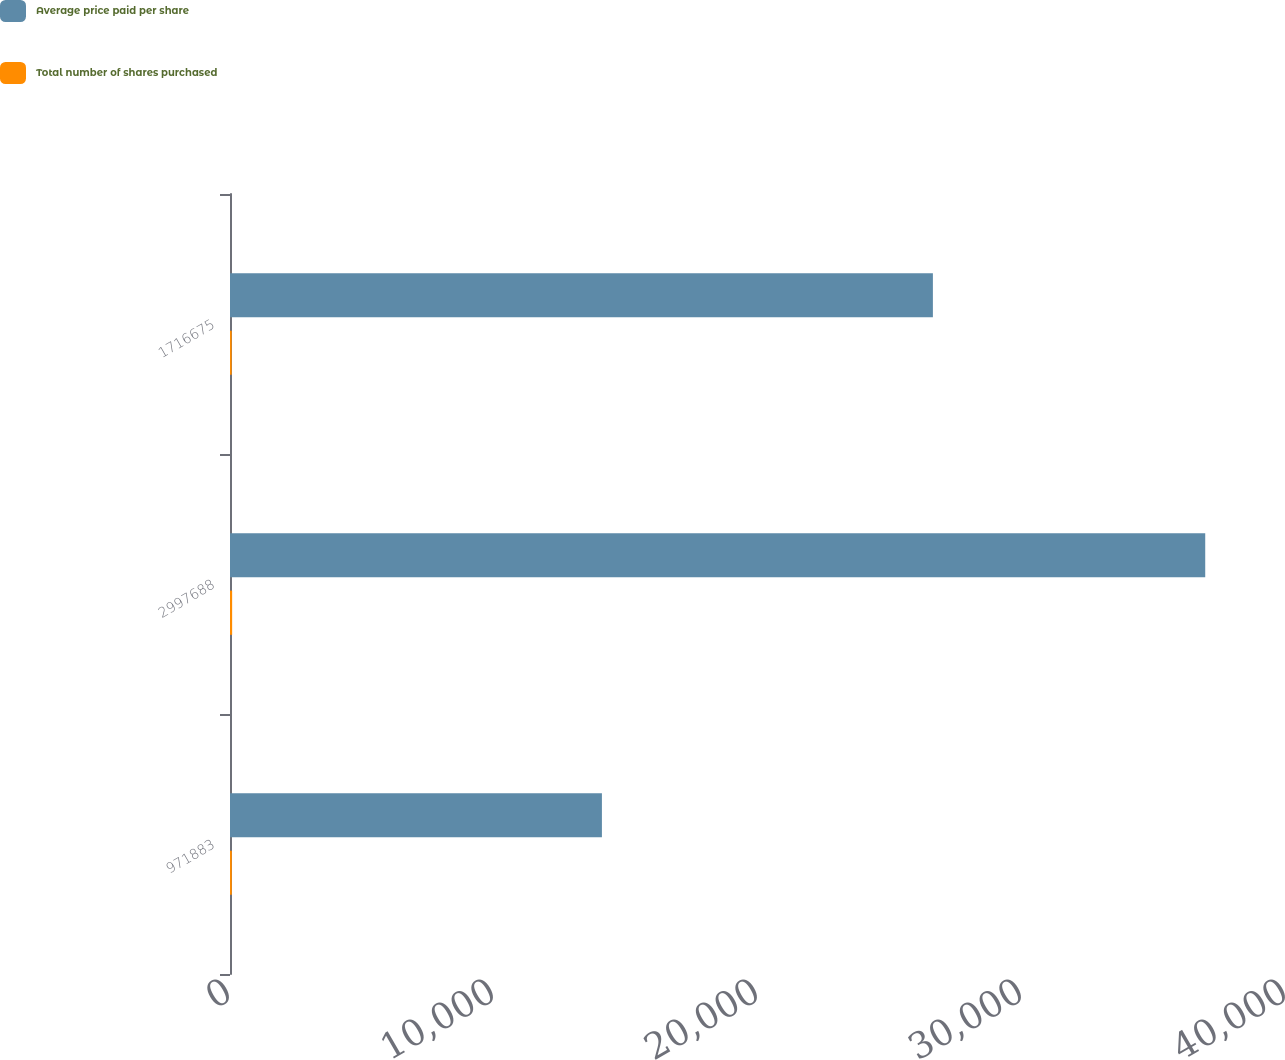<chart> <loc_0><loc_0><loc_500><loc_500><stacked_bar_chart><ecel><fcel>971883<fcel>2997688<fcel>1716675<nl><fcel>Average price paid per share<fcel>14087.8<fcel>36940.4<fcel>26624.8<nl><fcel>Total number of shares purchased<fcel>68.99<fcel>81.15<fcel>64.48<nl></chart> 